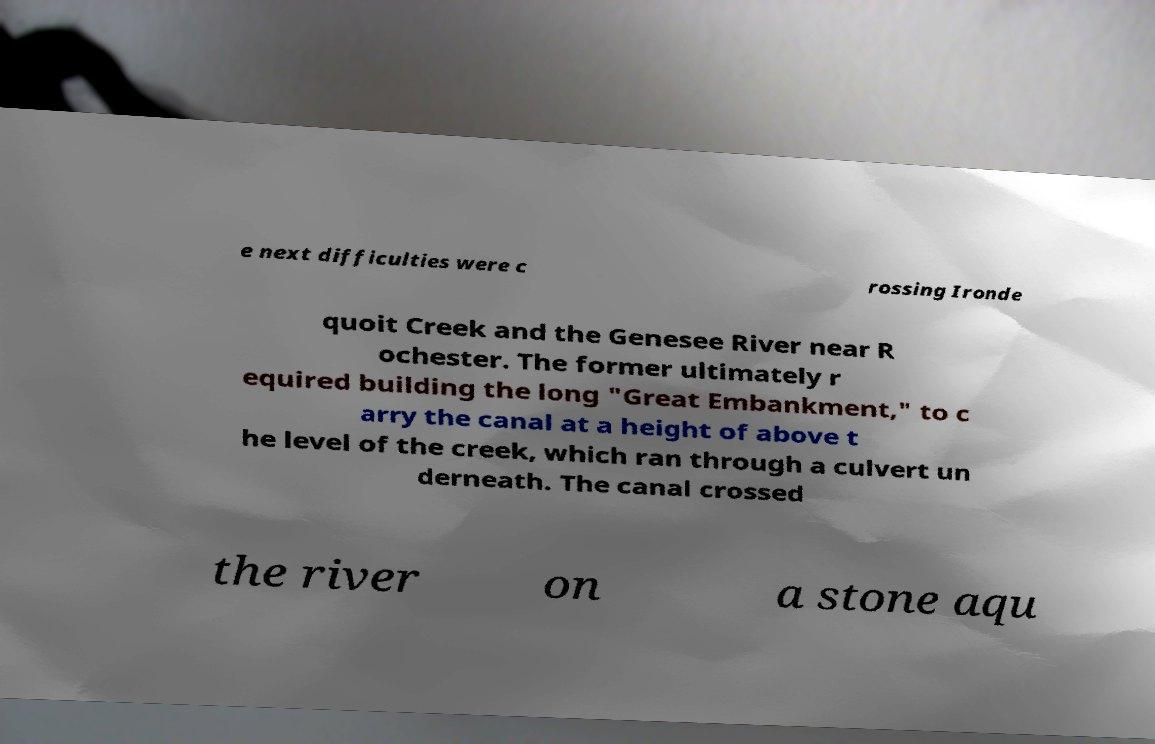I need the written content from this picture converted into text. Can you do that? e next difficulties were c rossing Ironde quoit Creek and the Genesee River near R ochester. The former ultimately r equired building the long "Great Embankment," to c arry the canal at a height of above t he level of the creek, which ran through a culvert un derneath. The canal crossed the river on a stone aqu 